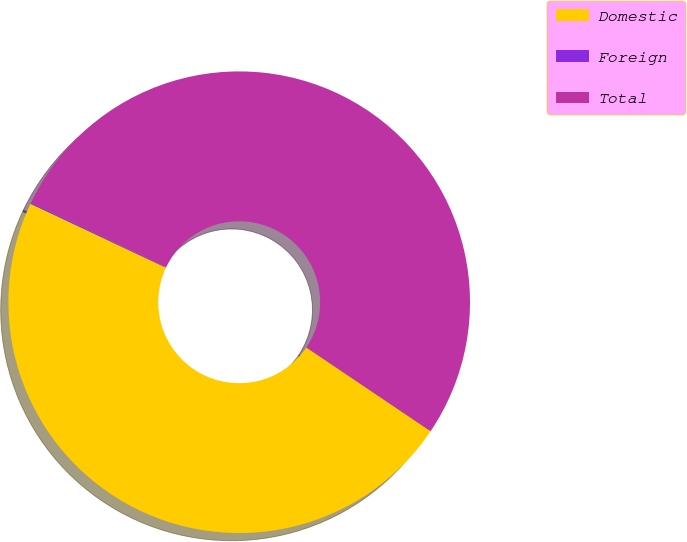Convert chart to OTSL. <chart><loc_0><loc_0><loc_500><loc_500><pie_chart><fcel>Domestic<fcel>Foreign<fcel>Total<nl><fcel>47.58%<fcel>0.09%<fcel>52.33%<nl></chart> 